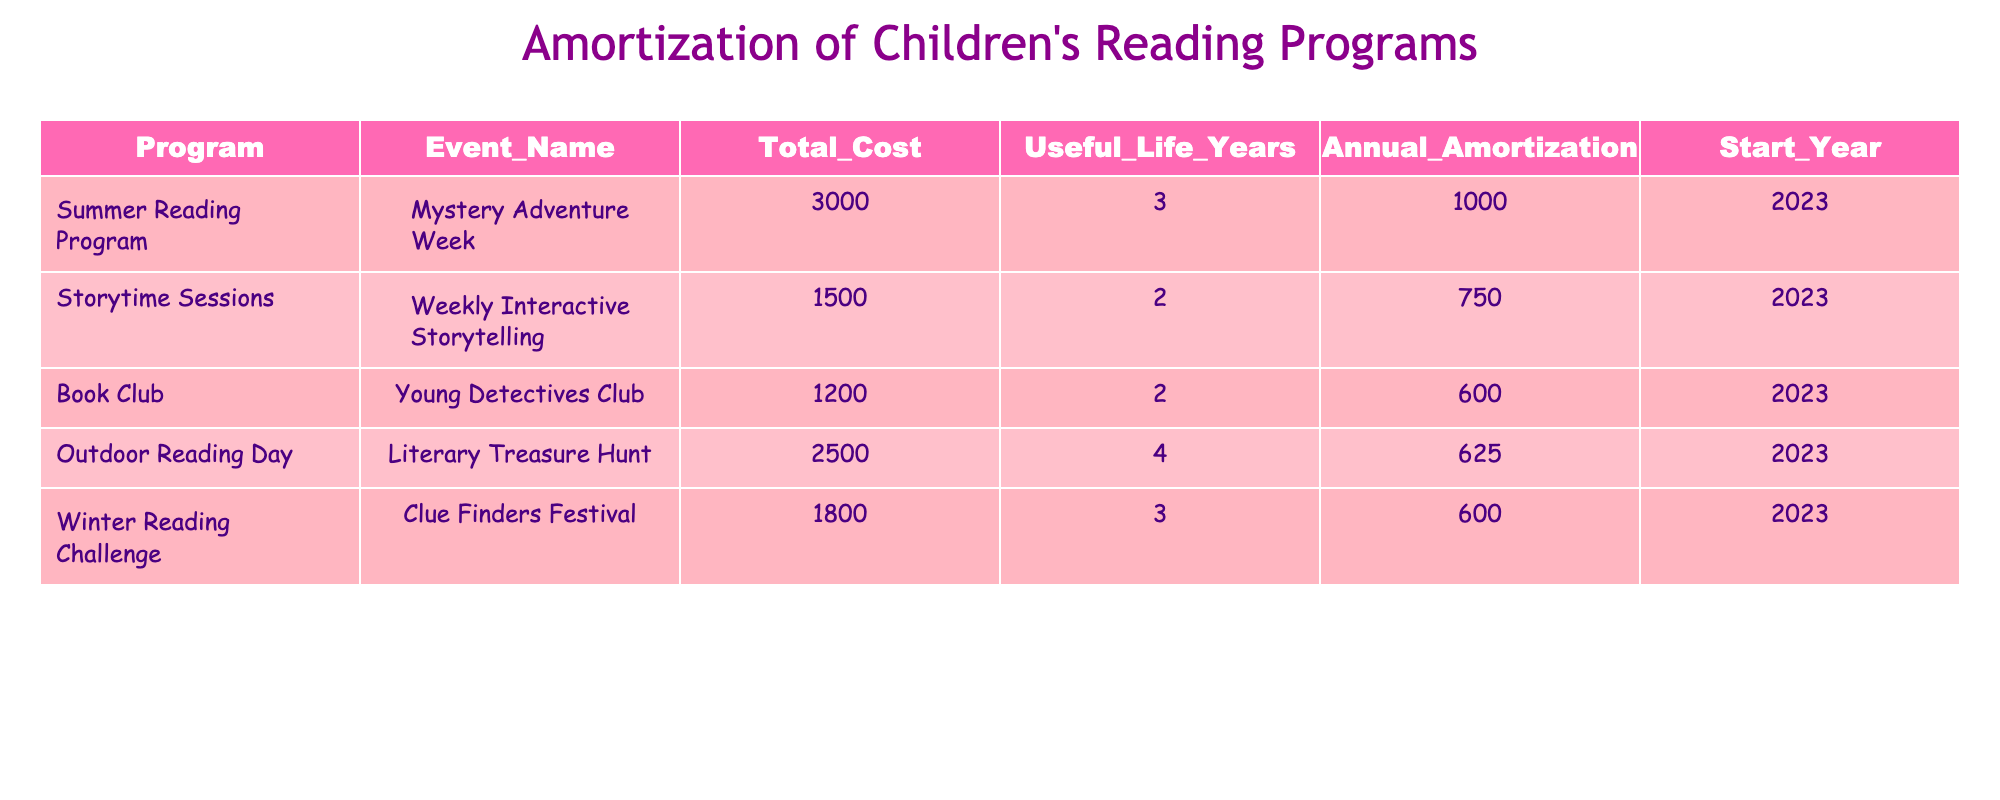What is the total cost for the "Outdoor Reading Day"? The total cost for the "Outdoor Reading Day" program is listed under the Total_Cost column, which shows a value of 2500.
Answer: 2500 What is the annual amortization for the "Young Detectives Club"? The annual amortization for the "Young Detectives Club" is provided in the Annual_Amortization column, which is 600.
Answer: 600 Is the "Winter Reading Challenge" amortized over more than 3 years? The amortization period for the "Winter Reading Challenge" is 3 years, as indicated in the Useful_Life_Years column, not more than 3 years.
Answer: No What is the average annual amortization across all programs listed? To find the average, sum the annual amortization values: 1000 + 750 + 600 + 625 + 600 = 3575. Then divide by the number of programs, which is 5. Thus, 3575 / 5 = 715.
Answer: 715 How much will be the total amortization for the "Mystery Adventure Week" by the end of its useful life? The total amortization can be found by multiplying the annual amortization (1000) by the useful life (3 years): 1000 * 3 = 3000.
Answer: 3000 Which program has the lowest annual amortization? By comparing all annual amortization values, we see that "Young Detectives Club" at 600 has the lowest value compared to others which are 1000, 750, 625, and 600.
Answer: Young Detectives Club What is the difference in total cost between the "Summer Reading Program" and the "Book Club"? The total cost for the "Summer Reading Program" is 3000, and for the "Book Club" it is 1200. The difference is calculated as 3000 - 1200 = 1800.
Answer: 1800 Does the "Literary Treasure Hunt" have a longer useful life than the "Weekly Interactive Storytelling"? The "Literary Treasure Hunt" has a useful life of 4 years, while the "Weekly Interactive Storytelling" has a useful life of 2 years. Since 4 is greater than 2, it does have a longer life.
Answer: Yes 